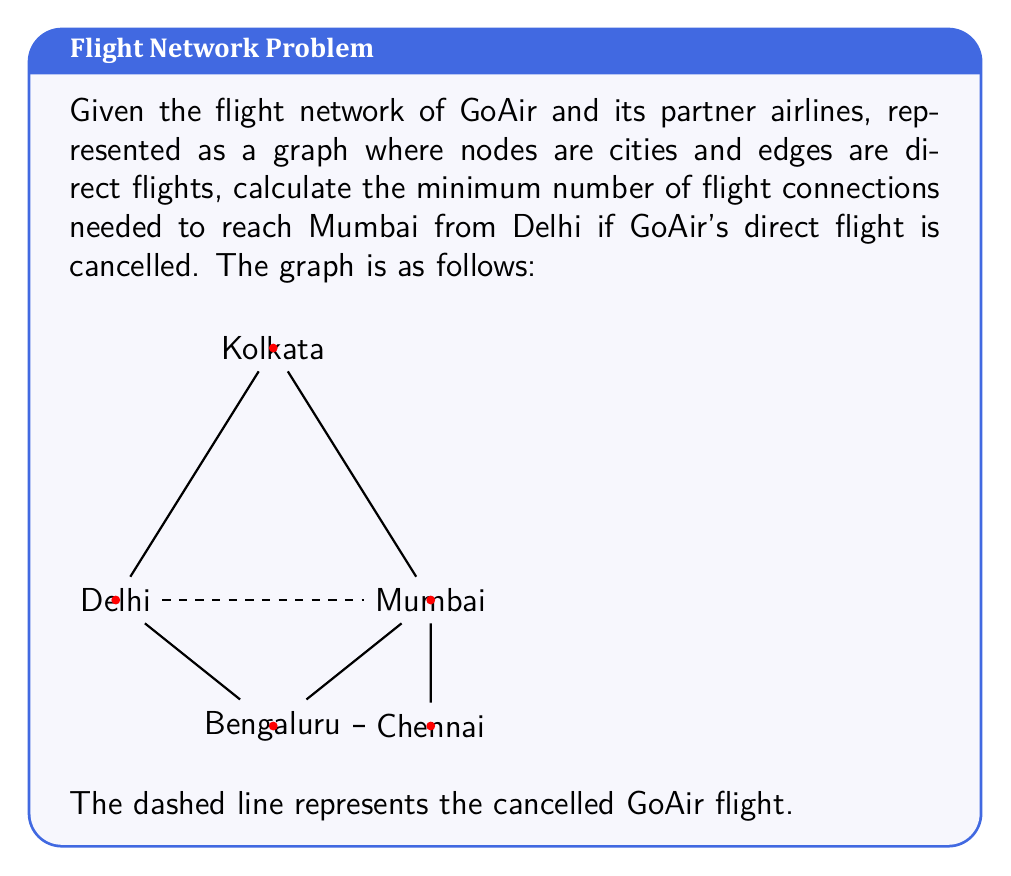Help me with this question. To solve this problem, we need to find the shortest path from Delhi to Mumbai in the given graph, excluding the direct flight (dashed line).

Let's analyze the possible routes:

1. Delhi → Kolkata → Mumbai
   Number of connections: 2

2. Delhi → Bengaluru → Mumbai
   Number of connections: 2

3. Delhi → Bengaluru → Chennai → Mumbai
   Number of connections: 3

We can represent this problem using graph theory concepts. Let $G = (V, E)$ be the graph where $V$ is the set of cities and $E$ is the set of available flights.

To find the minimum number of connections, we need to find the shortest path from Delhi to Mumbai. This can be done using breadth-first search (BFS) or Dijkstra's algorithm, but given the small size of the graph, we can solve it by inspection.

The shortest paths are:
1. Delhi → Kolkata → Mumbai
2. Delhi → Bengaluru → Mumbai

Both of these paths have a length of 2, meaning two connections are required.

To formalize this mathematically:

Let $d(u,v)$ be the distance (number of edges) between nodes $u$ and $v$ in the graph $G$.

The minimum number of connections is given by:

$$\min_{p \in P} (|p| - 1)$$

Where $P$ is the set of all paths from Delhi to Mumbai, and $|p|$ is the number of nodes in path $p$.

In this case, the minimum is achieved by the paths with 3 nodes (2 edges), resulting in 2 connections.
Answer: The minimum number of flight connections needed to reach Mumbai from Delhi is 2. 